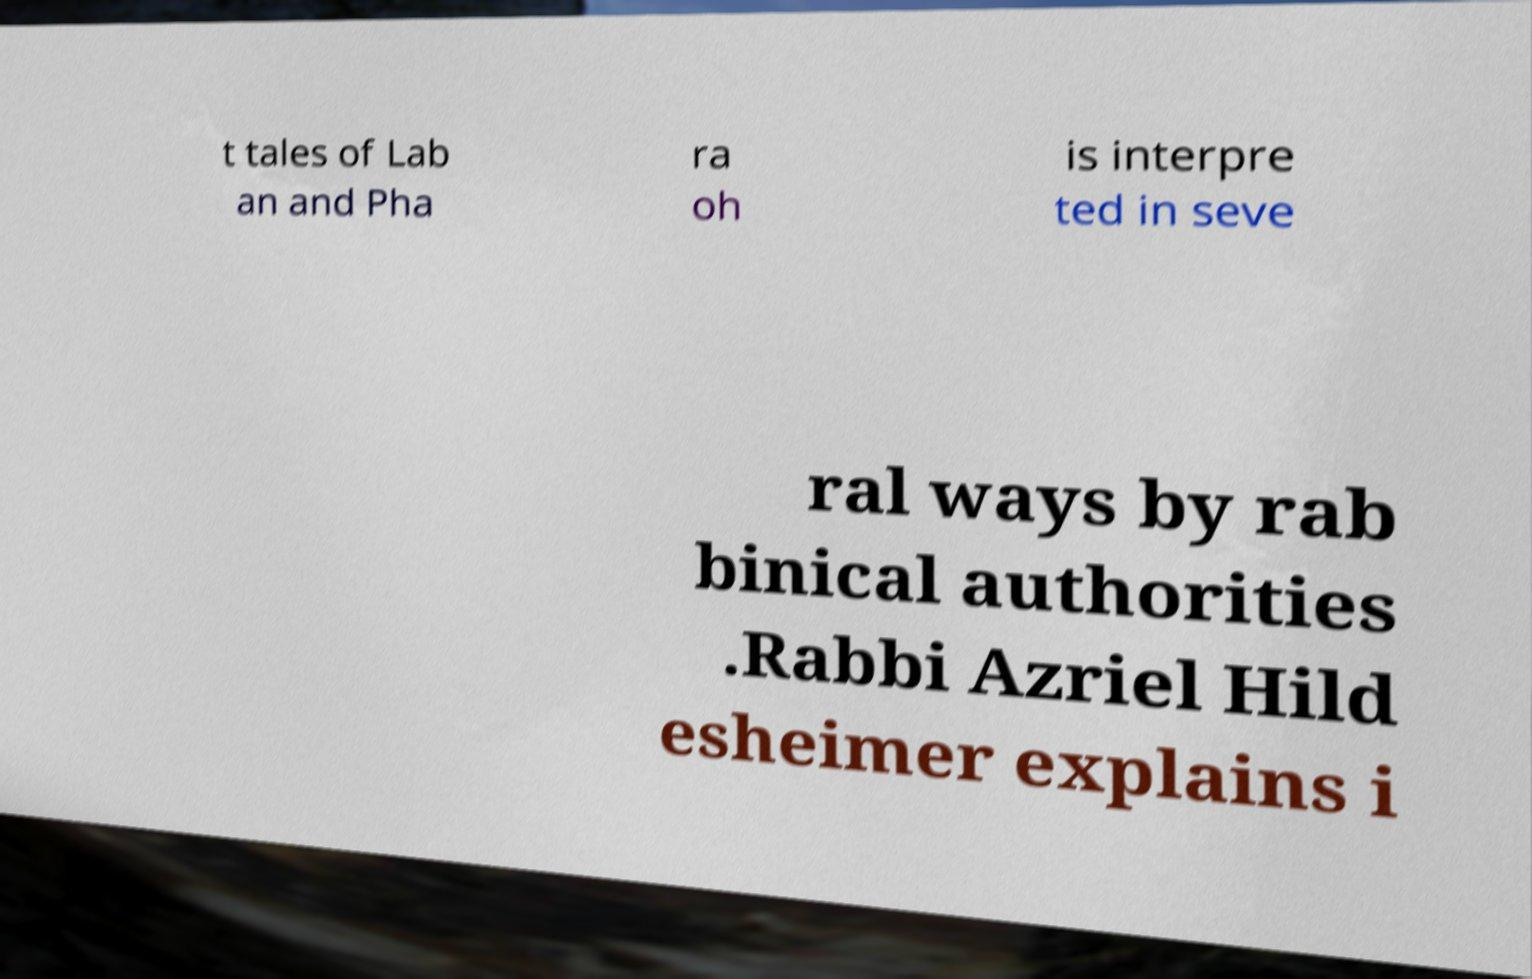Please identify and transcribe the text found in this image. t tales of Lab an and Pha ra oh is interpre ted in seve ral ways by rab binical authorities .Rabbi Azriel Hild esheimer explains i 